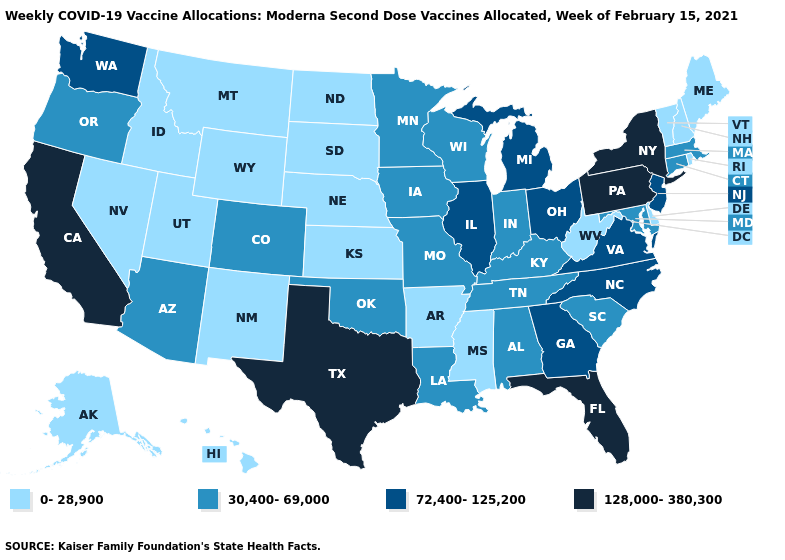Among the states that border Montana , which have the lowest value?
Quick response, please. Idaho, North Dakota, South Dakota, Wyoming. What is the lowest value in states that border Montana?
Write a very short answer. 0-28,900. Does Delaware have the same value as Louisiana?
Keep it brief. No. What is the value of New Hampshire?
Concise answer only. 0-28,900. Does Texas have the highest value in the USA?
Give a very brief answer. Yes. What is the lowest value in the West?
Answer briefly. 0-28,900. What is the lowest value in the Northeast?
Be succinct. 0-28,900. What is the value of South Carolina?
Write a very short answer. 30,400-69,000. Does Minnesota have the lowest value in the USA?
Write a very short answer. No. Name the states that have a value in the range 72,400-125,200?
Concise answer only. Georgia, Illinois, Michigan, New Jersey, North Carolina, Ohio, Virginia, Washington. What is the lowest value in the USA?
Write a very short answer. 0-28,900. Does Missouri have a lower value than Alaska?
Quick response, please. No. How many symbols are there in the legend?
Be succinct. 4. What is the value of Arizona?
Short answer required. 30,400-69,000. Name the states that have a value in the range 72,400-125,200?
Give a very brief answer. Georgia, Illinois, Michigan, New Jersey, North Carolina, Ohio, Virginia, Washington. 